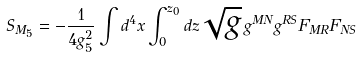Convert formula to latex. <formula><loc_0><loc_0><loc_500><loc_500>S _ { M _ { 5 } } = - \frac { 1 } { 4 g _ { 5 } ^ { 2 } } \int d ^ { 4 } x \int _ { 0 } ^ { z _ { 0 } } d z \sqrt { g } \, g ^ { M N } g ^ { R S } F _ { M R } F _ { N S }</formula> 